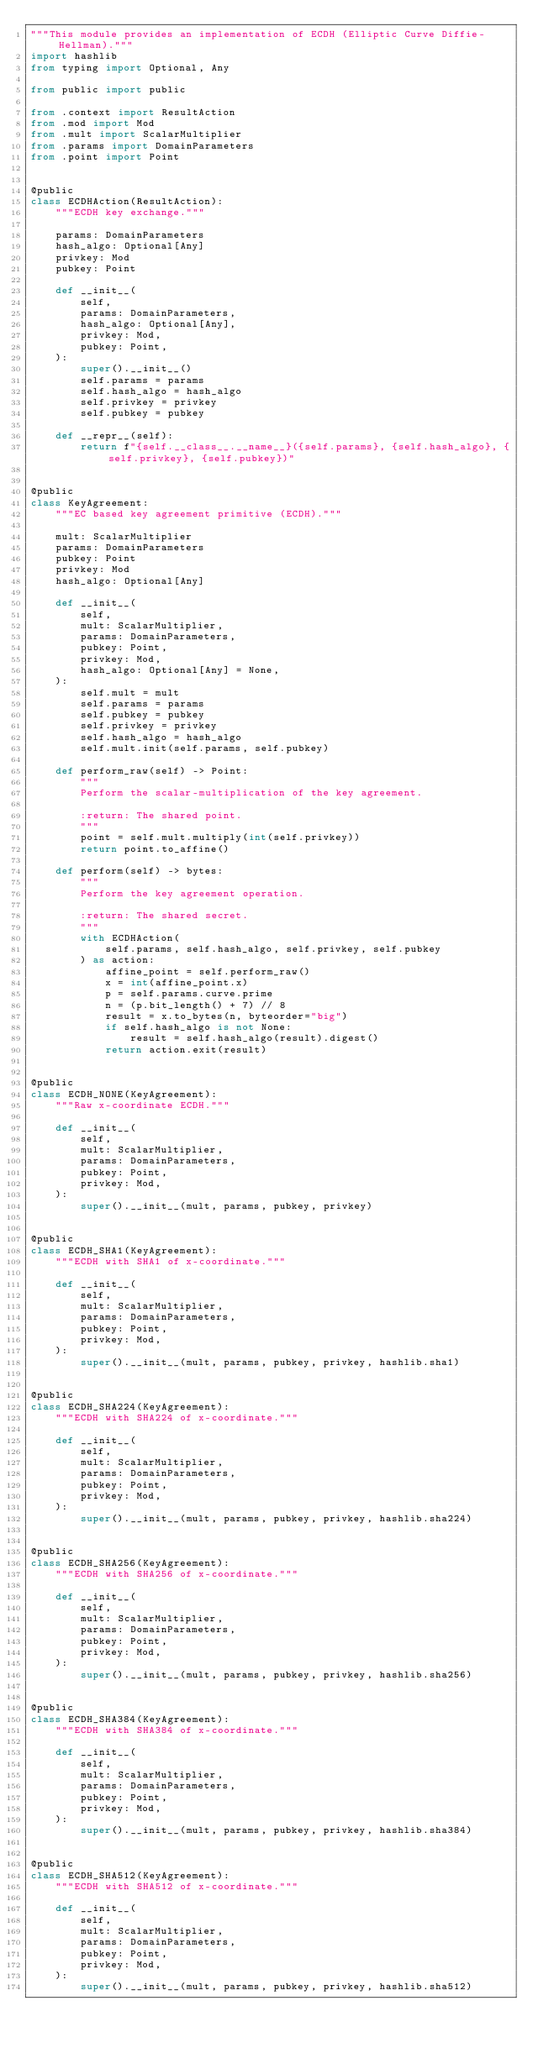Convert code to text. <code><loc_0><loc_0><loc_500><loc_500><_Python_>"""This module provides an implementation of ECDH (Elliptic Curve Diffie-Hellman)."""
import hashlib
from typing import Optional, Any

from public import public

from .context import ResultAction
from .mod import Mod
from .mult import ScalarMultiplier
from .params import DomainParameters
from .point import Point


@public
class ECDHAction(ResultAction):
    """ECDH key exchange."""

    params: DomainParameters
    hash_algo: Optional[Any]
    privkey: Mod
    pubkey: Point

    def __init__(
        self,
        params: DomainParameters,
        hash_algo: Optional[Any],
        privkey: Mod,
        pubkey: Point,
    ):
        super().__init__()
        self.params = params
        self.hash_algo = hash_algo
        self.privkey = privkey
        self.pubkey = pubkey

    def __repr__(self):
        return f"{self.__class__.__name__}({self.params}, {self.hash_algo}, {self.privkey}, {self.pubkey})"


@public
class KeyAgreement:
    """EC based key agreement primitive (ECDH)."""

    mult: ScalarMultiplier
    params: DomainParameters
    pubkey: Point
    privkey: Mod
    hash_algo: Optional[Any]

    def __init__(
        self,
        mult: ScalarMultiplier,
        params: DomainParameters,
        pubkey: Point,
        privkey: Mod,
        hash_algo: Optional[Any] = None,
    ):
        self.mult = mult
        self.params = params
        self.pubkey = pubkey
        self.privkey = privkey
        self.hash_algo = hash_algo
        self.mult.init(self.params, self.pubkey)

    def perform_raw(self) -> Point:
        """
        Perform the scalar-multiplication of the key agreement.

        :return: The shared point.
        """
        point = self.mult.multiply(int(self.privkey))
        return point.to_affine()

    def perform(self) -> bytes:
        """
        Perform the key agreement operation.

        :return: The shared secret.
        """
        with ECDHAction(
            self.params, self.hash_algo, self.privkey, self.pubkey
        ) as action:
            affine_point = self.perform_raw()
            x = int(affine_point.x)
            p = self.params.curve.prime
            n = (p.bit_length() + 7) // 8
            result = x.to_bytes(n, byteorder="big")
            if self.hash_algo is not None:
                result = self.hash_algo(result).digest()
            return action.exit(result)


@public
class ECDH_NONE(KeyAgreement):
    """Raw x-coordinate ECDH."""

    def __init__(
        self,
        mult: ScalarMultiplier,
        params: DomainParameters,
        pubkey: Point,
        privkey: Mod,
    ):
        super().__init__(mult, params, pubkey, privkey)


@public
class ECDH_SHA1(KeyAgreement):
    """ECDH with SHA1 of x-coordinate."""

    def __init__(
        self,
        mult: ScalarMultiplier,
        params: DomainParameters,
        pubkey: Point,
        privkey: Mod,
    ):
        super().__init__(mult, params, pubkey, privkey, hashlib.sha1)


@public
class ECDH_SHA224(KeyAgreement):
    """ECDH with SHA224 of x-coordinate."""

    def __init__(
        self,
        mult: ScalarMultiplier,
        params: DomainParameters,
        pubkey: Point,
        privkey: Mod,
    ):
        super().__init__(mult, params, pubkey, privkey, hashlib.sha224)


@public
class ECDH_SHA256(KeyAgreement):
    """ECDH with SHA256 of x-coordinate."""

    def __init__(
        self,
        mult: ScalarMultiplier,
        params: DomainParameters,
        pubkey: Point,
        privkey: Mod,
    ):
        super().__init__(mult, params, pubkey, privkey, hashlib.sha256)


@public
class ECDH_SHA384(KeyAgreement):
    """ECDH with SHA384 of x-coordinate."""

    def __init__(
        self,
        mult: ScalarMultiplier,
        params: DomainParameters,
        pubkey: Point,
        privkey: Mod,
    ):
        super().__init__(mult, params, pubkey, privkey, hashlib.sha384)


@public
class ECDH_SHA512(KeyAgreement):
    """ECDH with SHA512 of x-coordinate."""

    def __init__(
        self,
        mult: ScalarMultiplier,
        params: DomainParameters,
        pubkey: Point,
        privkey: Mod,
    ):
        super().__init__(mult, params, pubkey, privkey, hashlib.sha512)
</code> 